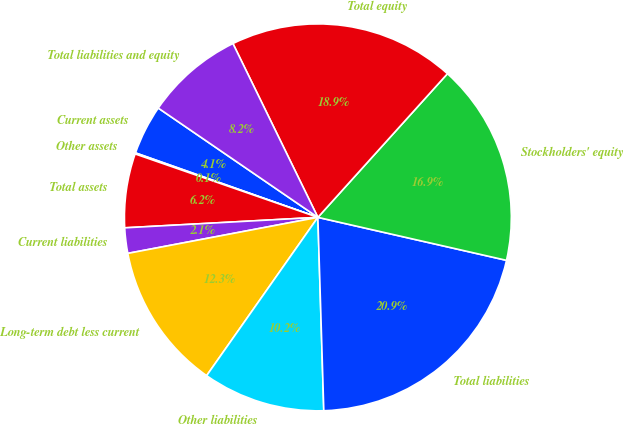<chart> <loc_0><loc_0><loc_500><loc_500><pie_chart><fcel>Current assets<fcel>Other assets<fcel>Total assets<fcel>Current liabilities<fcel>Long-term debt less current<fcel>Other liabilities<fcel>Total liabilities<fcel>Stockholders' equity<fcel>Total equity<fcel>Total liabilities and equity<nl><fcel>4.15%<fcel>0.09%<fcel>6.18%<fcel>2.12%<fcel>12.27%<fcel>10.24%<fcel>20.95%<fcel>16.89%<fcel>18.92%<fcel>8.21%<nl></chart> 